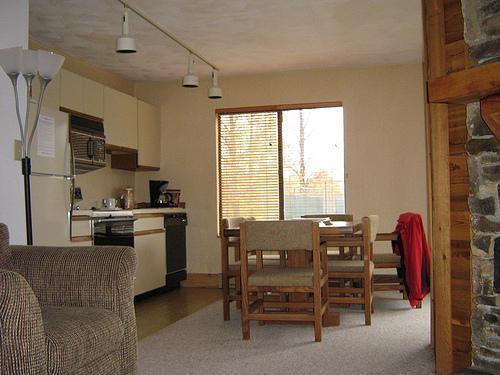How many fixtures in the ceiling?
Give a very brief answer. 3. How many places are there to sit down?
Give a very brief answer. 5. How many chairs are in the picture?
Give a very brief answer. 4. How many doors on the bus are open?
Give a very brief answer. 0. 